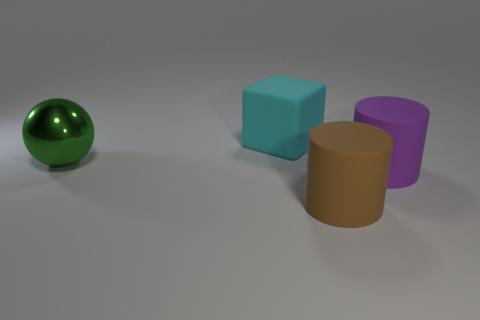Is there another metal thing that has the same shape as the cyan thing?
Keep it short and to the point. No. Do the cyan object and the large metal thing have the same shape?
Make the answer very short. No. There is a big object that is to the left of the rubber object behind the big shiny object; what is its color?
Provide a short and direct response. Green. What color is the matte cylinder that is the same size as the purple matte object?
Your answer should be very brief. Brown. How many rubber things are either yellow objects or big green objects?
Offer a very short reply. 0. How many brown matte things are in front of the matte cube on the left side of the large brown cylinder?
Your answer should be compact. 1. How many things are either small green matte things or big brown cylinders to the right of the matte cube?
Make the answer very short. 1. Are there any cyan cubes made of the same material as the brown object?
Provide a succinct answer. Yes. How many big rubber things are both on the left side of the large purple matte cylinder and in front of the green ball?
Give a very brief answer. 1. There is a sphere that is behind the purple object; what is its material?
Keep it short and to the point. Metal. 